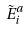Convert formula to latex. <formula><loc_0><loc_0><loc_500><loc_500>\tilde { E } _ { i } ^ { a }</formula> 